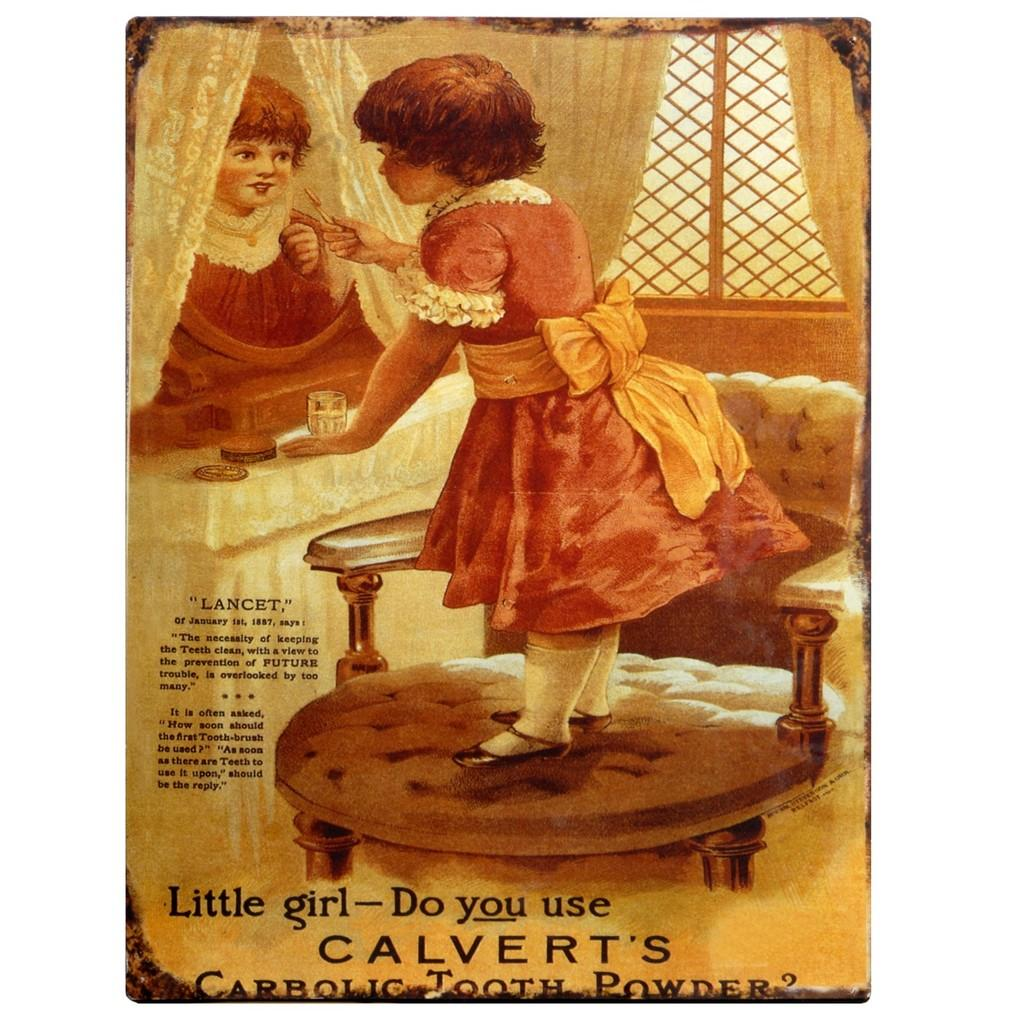What is the main subject of the poster in the image? The poster depicts a girl standing on a chair. What is the girl doing in the poster? The girl is in front of a mirror and holding a brush. Is there any text on the poster? Yes, there is text is present on the poster. How many skies can be seen in the image? There is no sky visible in the image; the focus is on the poster featuring the girl. What type of scale is used by the girl to measure her height in the image? There is no scale present in the image; the girl is standing on a chair. 